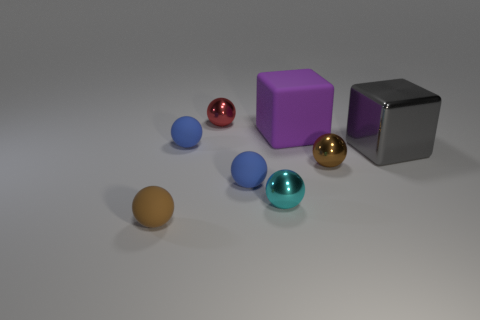Subtract 3 balls. How many balls are left? 3 Subtract all brown spheres. How many spheres are left? 4 Subtract all brown matte spheres. How many spheres are left? 5 Subtract all gray spheres. Subtract all green blocks. How many spheres are left? 6 Add 1 red rubber cylinders. How many objects exist? 9 Subtract all balls. How many objects are left? 2 Subtract all large gray cubes. Subtract all blue things. How many objects are left? 5 Add 2 big metallic things. How many big metallic things are left? 3 Add 8 small gray matte blocks. How many small gray matte blocks exist? 8 Subtract 0 brown cylinders. How many objects are left? 8 